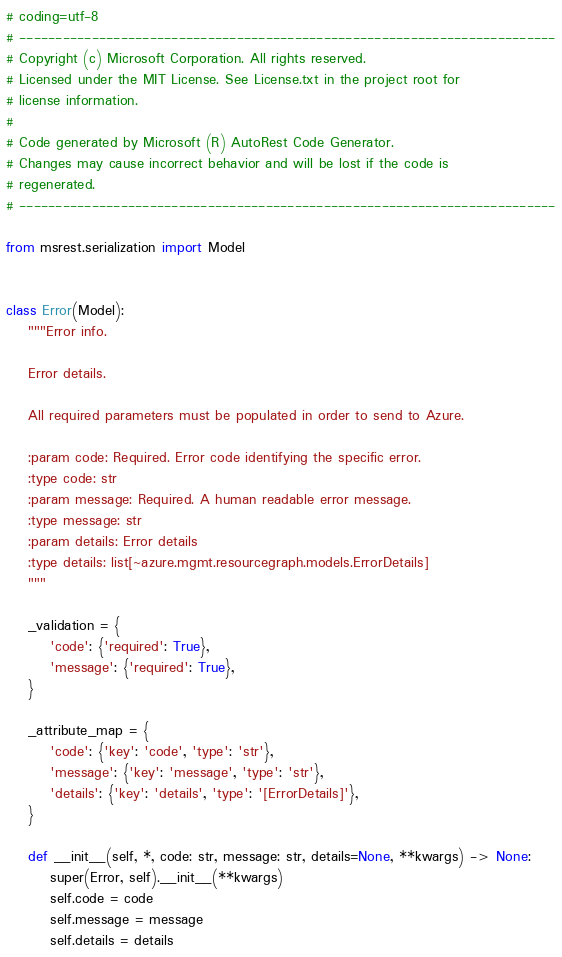<code> <loc_0><loc_0><loc_500><loc_500><_Python_># coding=utf-8
# --------------------------------------------------------------------------
# Copyright (c) Microsoft Corporation. All rights reserved.
# Licensed under the MIT License. See License.txt in the project root for
# license information.
#
# Code generated by Microsoft (R) AutoRest Code Generator.
# Changes may cause incorrect behavior and will be lost if the code is
# regenerated.
# --------------------------------------------------------------------------

from msrest.serialization import Model


class Error(Model):
    """Error info.

    Error details.

    All required parameters must be populated in order to send to Azure.

    :param code: Required. Error code identifying the specific error.
    :type code: str
    :param message: Required. A human readable error message.
    :type message: str
    :param details: Error details
    :type details: list[~azure.mgmt.resourcegraph.models.ErrorDetails]
    """

    _validation = {
        'code': {'required': True},
        'message': {'required': True},
    }

    _attribute_map = {
        'code': {'key': 'code', 'type': 'str'},
        'message': {'key': 'message', 'type': 'str'},
        'details': {'key': 'details', 'type': '[ErrorDetails]'},
    }

    def __init__(self, *, code: str, message: str, details=None, **kwargs) -> None:
        super(Error, self).__init__(**kwargs)
        self.code = code
        self.message = message
        self.details = details
</code> 